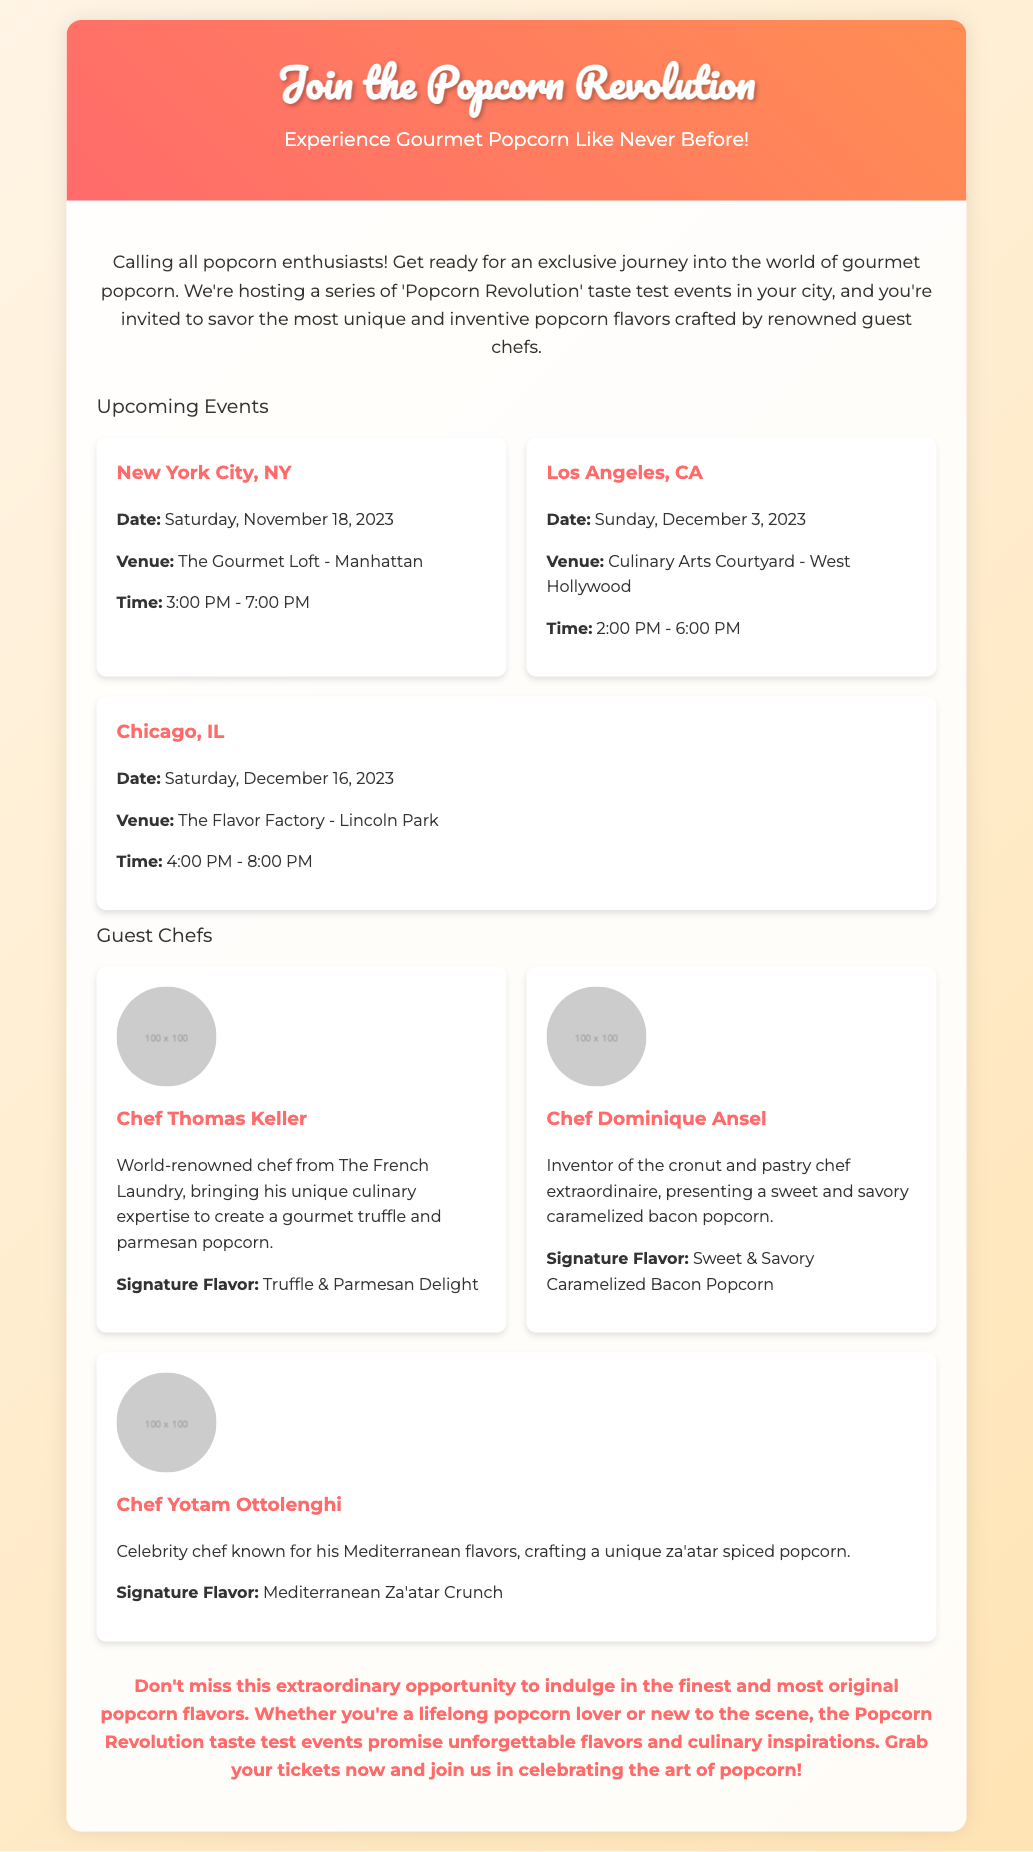what is the title of the event? The title of the event is mentioned in the header of the advertisement as "Join the Popcorn Revolution."
Answer: Join the Popcorn Revolution when is the New York City event scheduled? The date for the New York City event is provided in the event details section of the document.
Answer: Saturday, November 18, 2023 where will the Los Angeles event take place? The venue for the Los Angeles event is specified in the event details.
Answer: Culinary Arts Courtyard - West Hollywood who is the guest chef known for truffle popcorn? The chef's name is mentioned along with their signature flavor in the guest chefs section.
Answer: Chef Thomas Keller what is the signature flavor created by Chef Dominique Ansel? The signature flavor is noted in the chef's profile in the advertisement.
Answer: Sweet & Savory Caramelized Bacon Popcorn how many events are listed in the advertisement? The total number of events can be calculated by counting the event cards presented in the document.
Answer: 3 which chef is recognized for Mediterranean flavors? This information is found in the chef profiles where specialties are highlighted.
Answer: Chef Yotam Ottolenghi what is the time for the Chicago event? The time for the Chicago event is included in the event details section of the document.
Answer: 4:00 PM - 8:00 PM what type of document is this? The general purpose and format of the content indicate its nature as an advertisement for an event.
Answer: Advertisement 